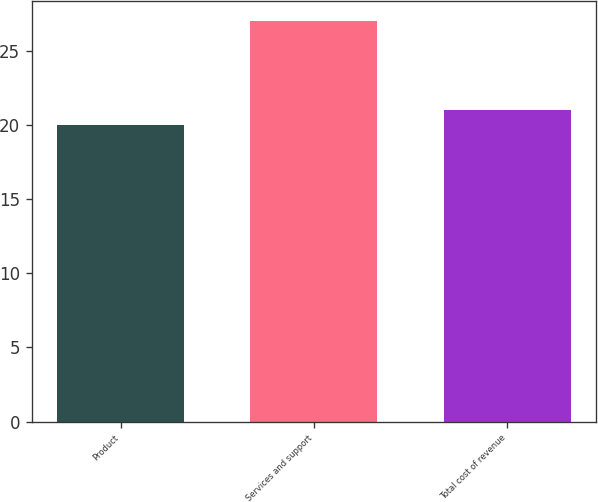Convert chart to OTSL. <chart><loc_0><loc_0><loc_500><loc_500><bar_chart><fcel>Product<fcel>Services and support<fcel>Total cost of revenue<nl><fcel>20<fcel>27<fcel>21<nl></chart> 